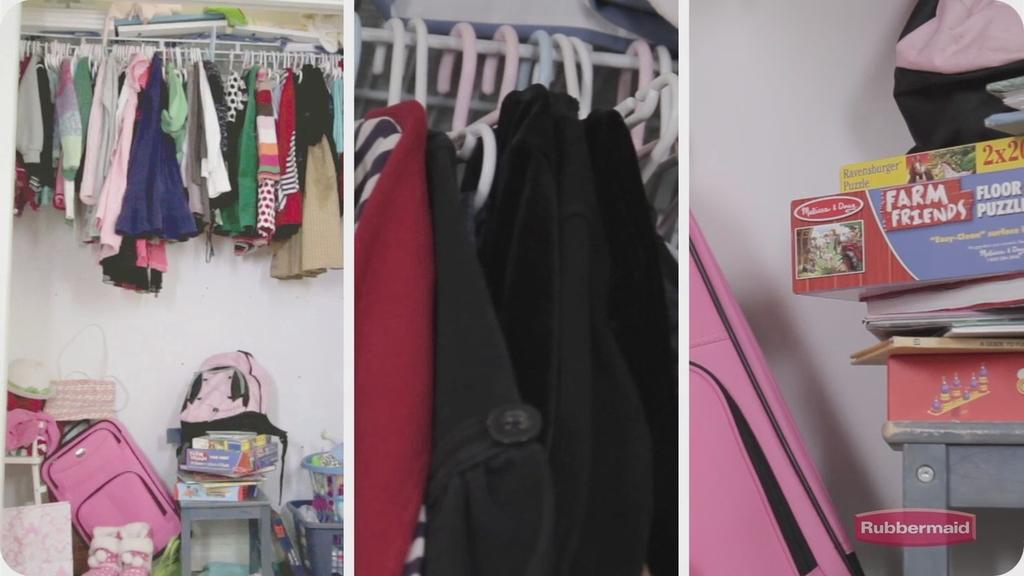<image>
Share a concise interpretation of the image provided. A puzzle game inside a closet on top of books 